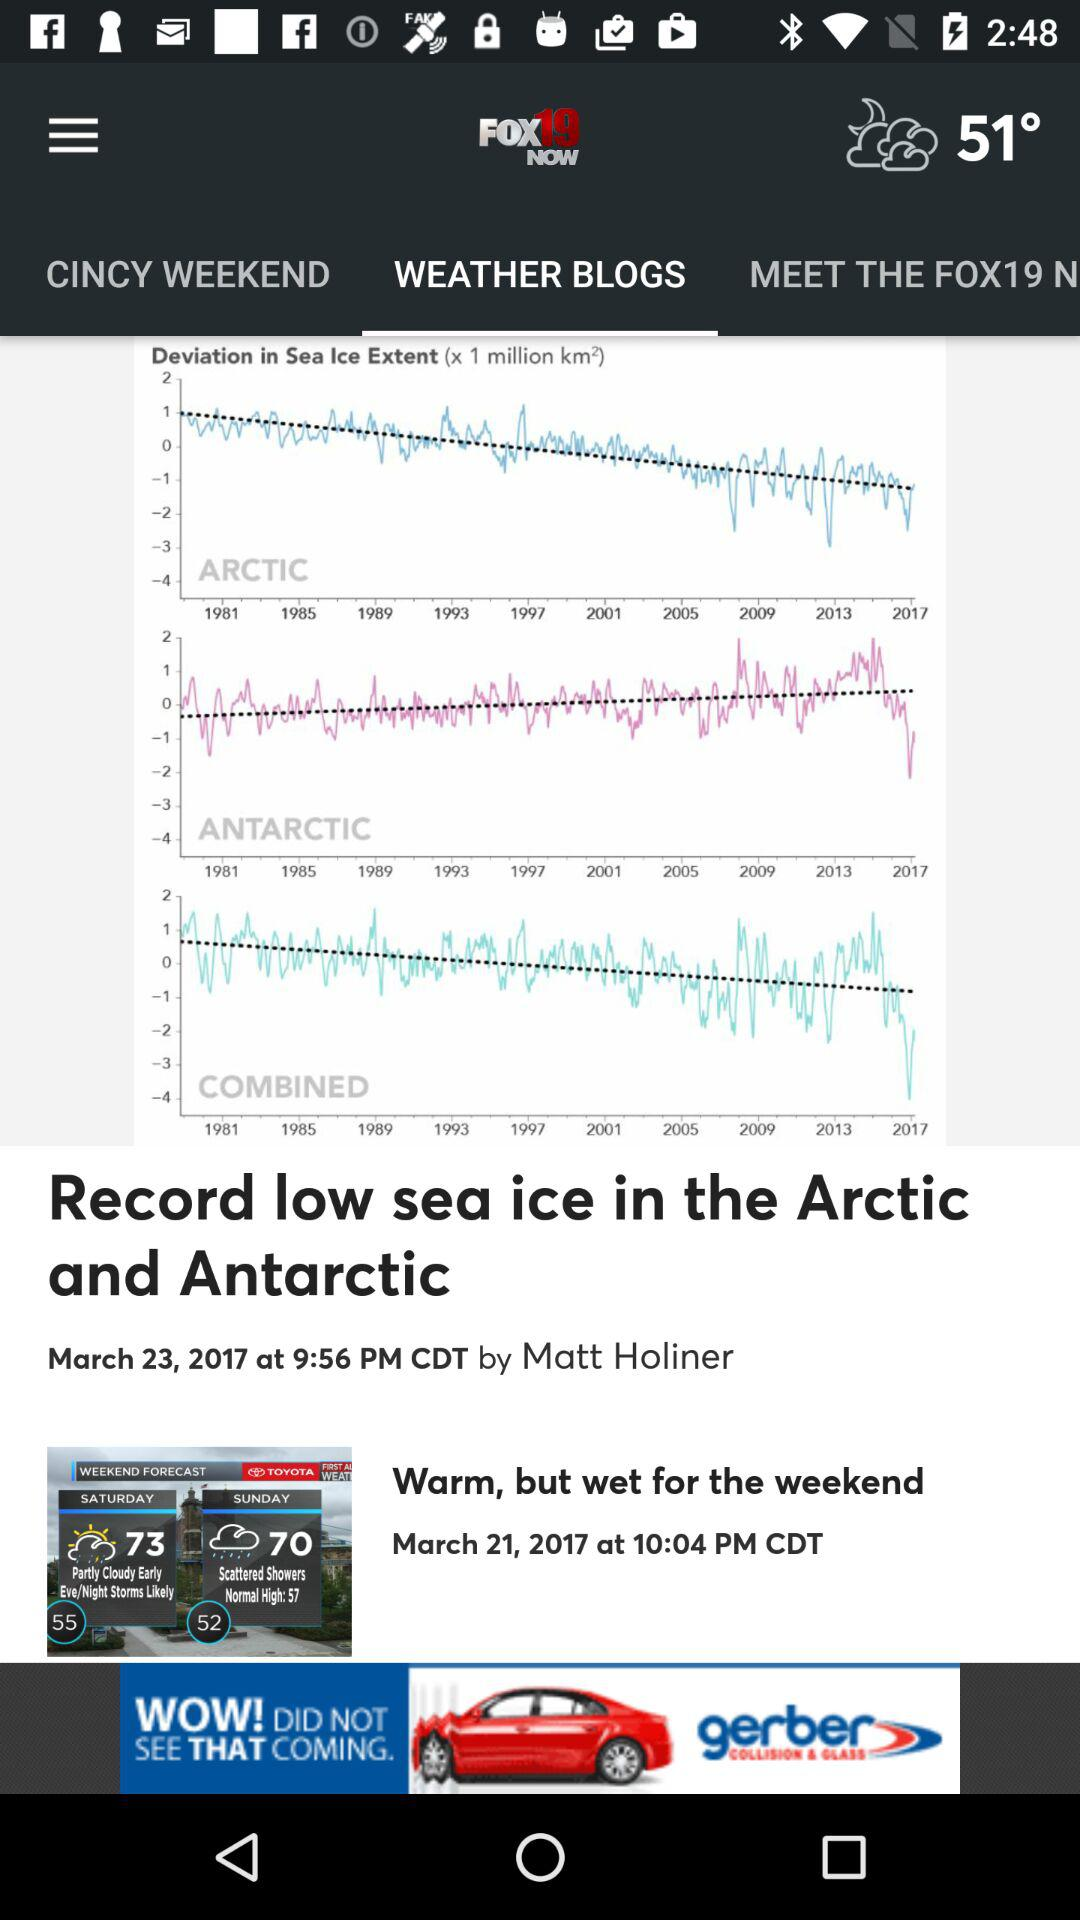What is the name of the application? The name of the application is "FOX19 NOW". 